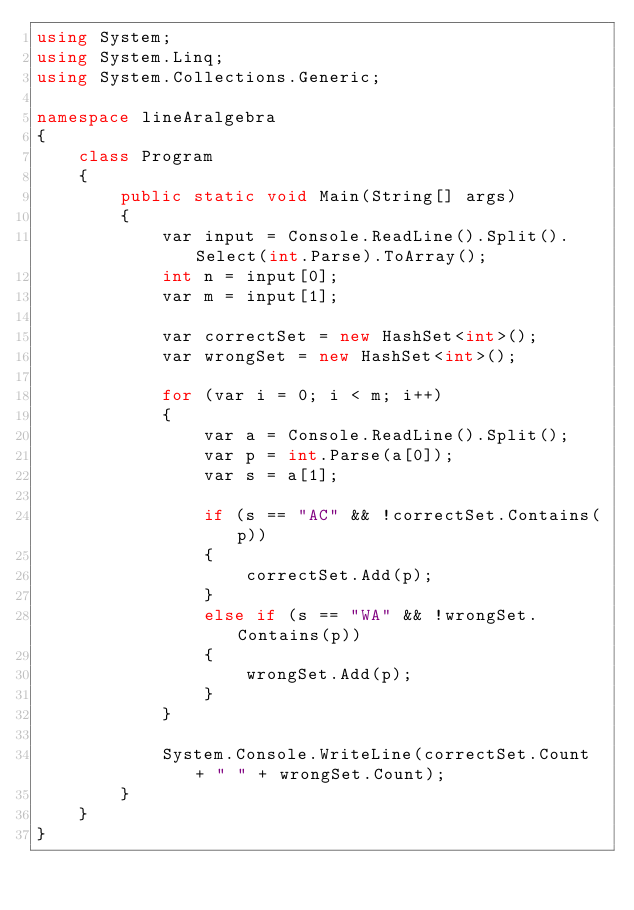<code> <loc_0><loc_0><loc_500><loc_500><_C#_>using System;
using System.Linq;
using System.Collections.Generic;

namespace lineAralgebra
{
	class Program
	{
		public static void Main(String[] args)
		{
			var input = Console.ReadLine().Split().Select(int.Parse).ToArray();
			int n = input[0];
			var m = input[1];

			var correctSet = new HashSet<int>();
			var wrongSet = new HashSet<int>();

			for (var i = 0; i < m; i++)
			{
				var a = Console.ReadLine().Split();
				var p = int.Parse(a[0]);
				var s = a[1];

				if (s == "AC" && !correctSet.Contains(p))
				{
					correctSet.Add(p);
				}
				else if (s == "WA" && !wrongSet.Contains(p))
				{
					wrongSet.Add(p);
				}
			}

			System.Console.WriteLine(correctSet.Count + " " + wrongSet.Count);
		}
	}
}

</code> 